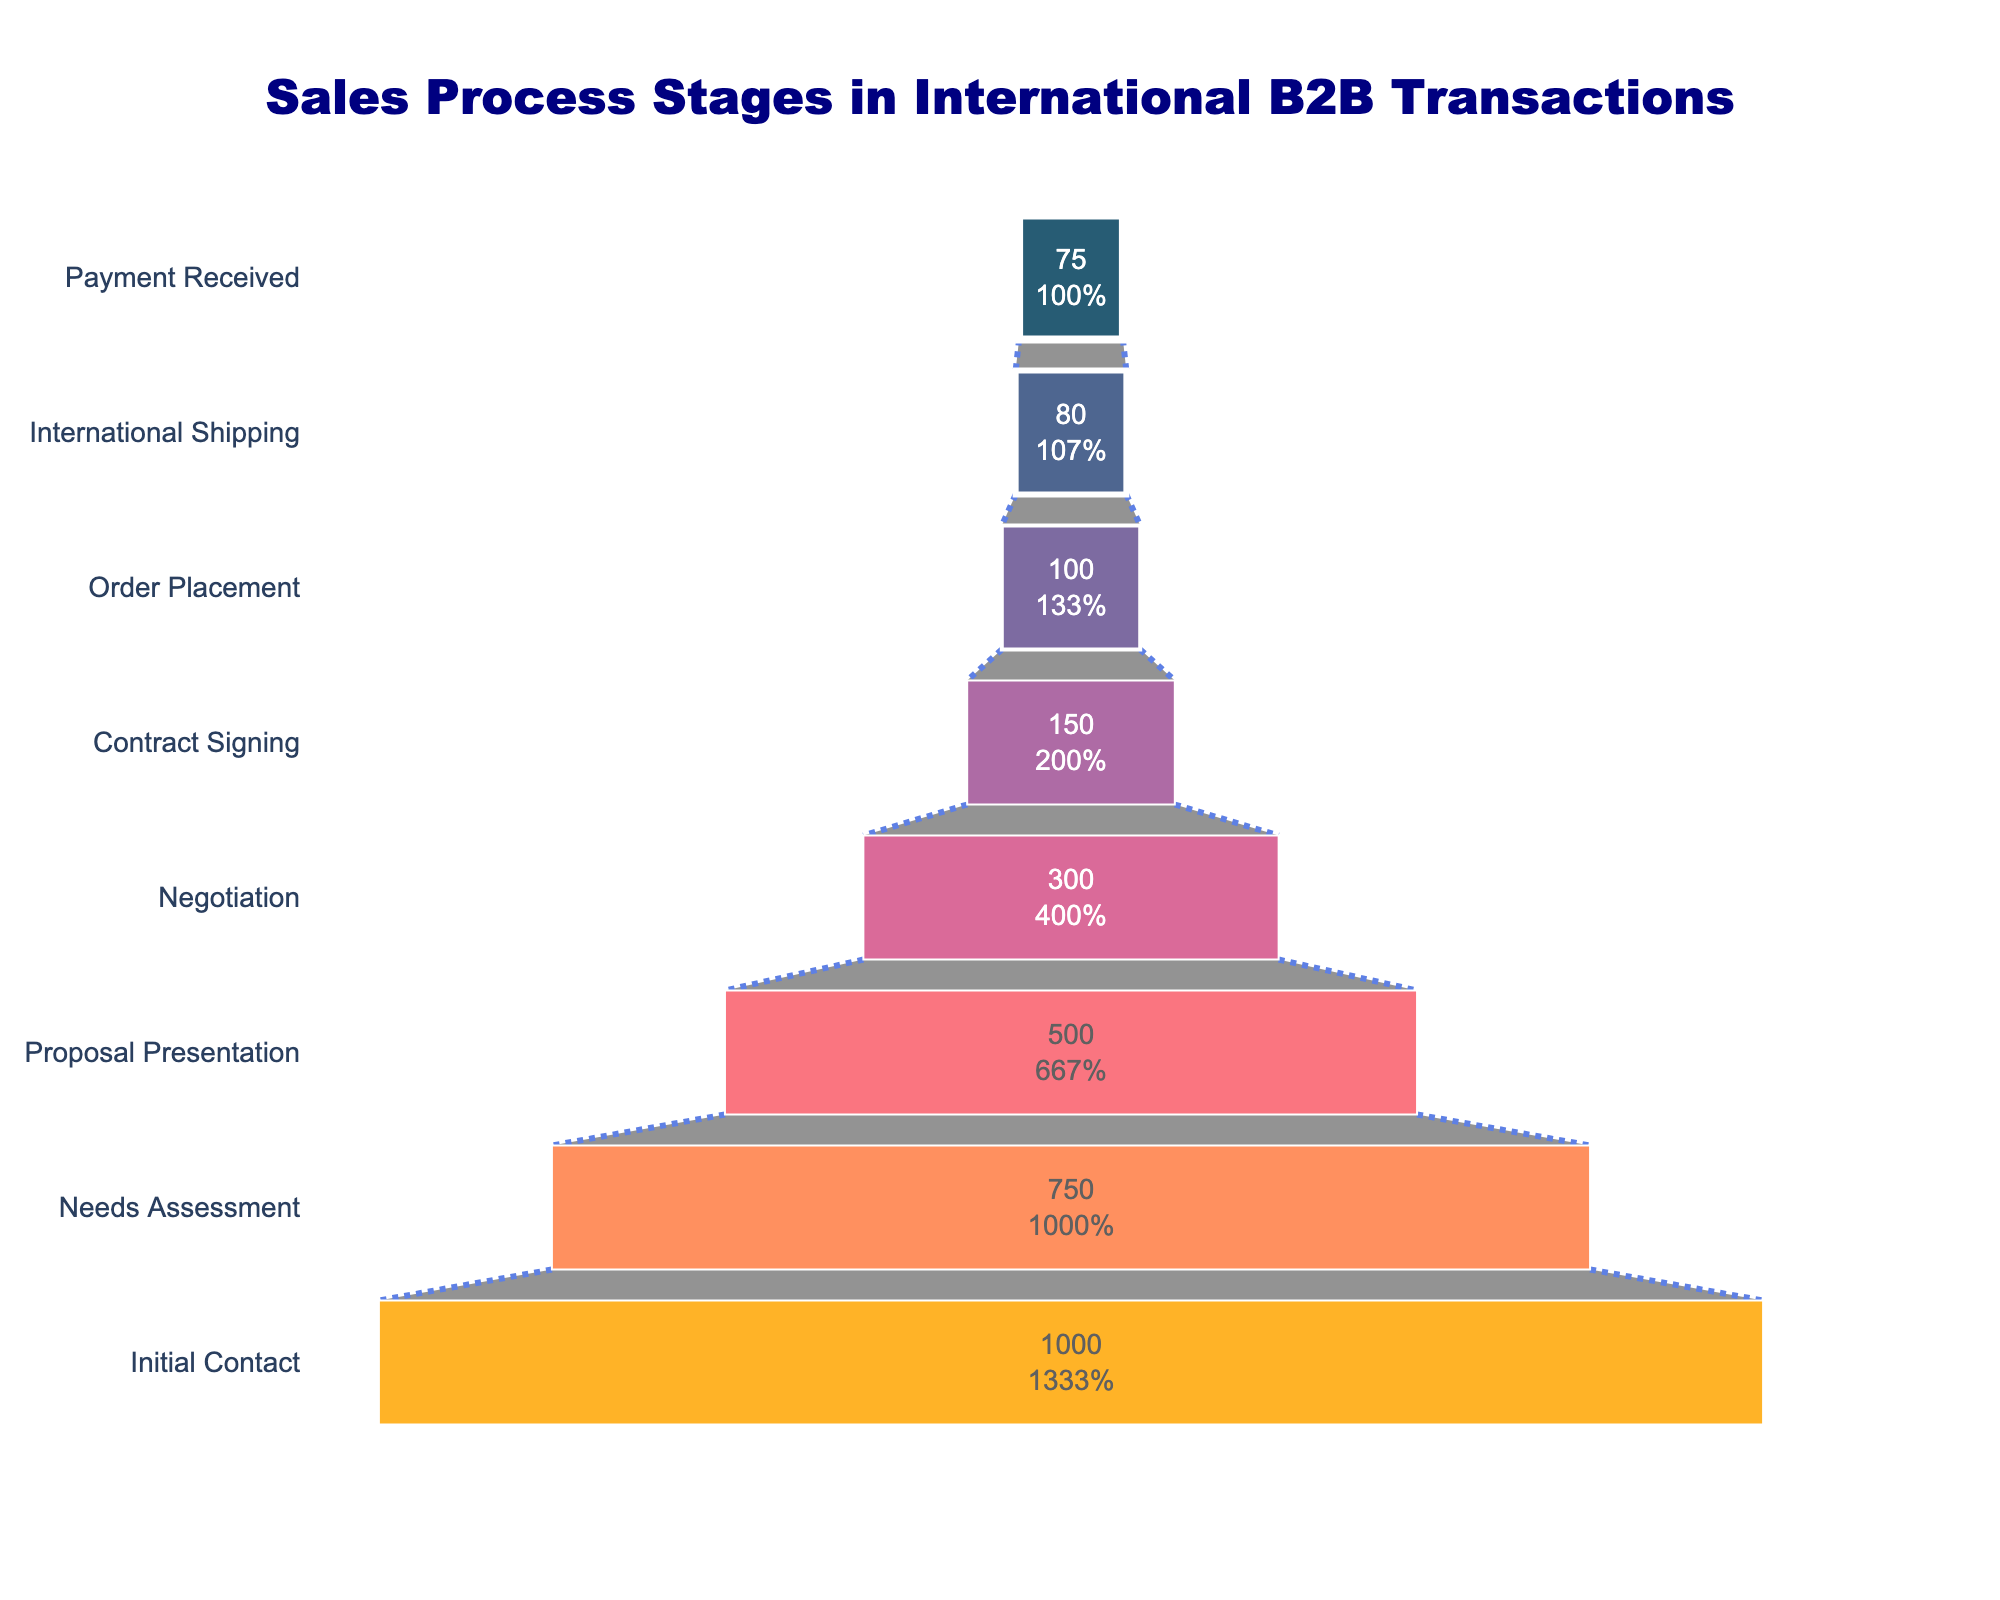What is the title of the chart? The title of the chart is the text displayed at the top of the funnel chart. In this case, it is prominently visible above the stages.
Answer: Sales Process Stages in International B2B Transactions How many stages are there in the sales process? To determine the number of stages, count the different blocks representing each stage in the funnel chart.
Answer: 8 What percentage of prospects proceed from Proposal Presentation to Negotiation? Look at the value and percentage inside the funnel block for the Proposal Presentation stage and compare it with the Negotiation stage. Calculate the percentage of 300 (Negotiation) out of 500 (Proposal Presentation).
Answer: 60% What is the reduction in the number of prospects from Initial Contact to Needs Assessment? Calculate the difference in the number of prospects between these two stages: 1000 (Initial Contact) minus 750 (Needs Assessment).
Answer: 250 Which stage shows the smallest number of prospects? Identify the stage with the lowest value inside its funnel block. The stage with 75 is the smallest number of prospects.
Answer: Payment Received How many prospects are lost between Contract Signing and Order Placement stages? Subtract the number of prospects at Order Placement from those at Contract Signing: 150 (Contract Signing) minus 100 (Order Placement).
Answer: 50 By what percentage does the number of prospects decrease from Order Placement to International Shipping? Determine the percentage decrease using the number of prospects at these stages: [(100 - 80) / 100] * 100. Calculate the values accordingly.
Answer: 20% Is the percentage drop greater from Negotiation to Contract Signing or from International Shipping to Payment Received? Compare the percentage drops calculated for each pair of stages: Negotiation to Contract Signing [(300 - 150)/300]*100 and International Shipping to Payment Received [(80 - 75)/80]*100.
Answer: Negotiation to Contract Signing What is the total number of prospects at the last three stages combined? Sum the number of prospects in the last three stages: 80 (International Shipping) + 75 (Payment Received) + 100 (Order Placement).
Answer: 255 Which stage represents nearly half the number of initial contacts? Identify the stage where the number of prospects is approximately half of the initial contacts by comparing values. Divide the initial contact value by 2 for estimation. Needs Assessment (750) is closest to half of 1000 (500).
Answer: Needs Assessment 